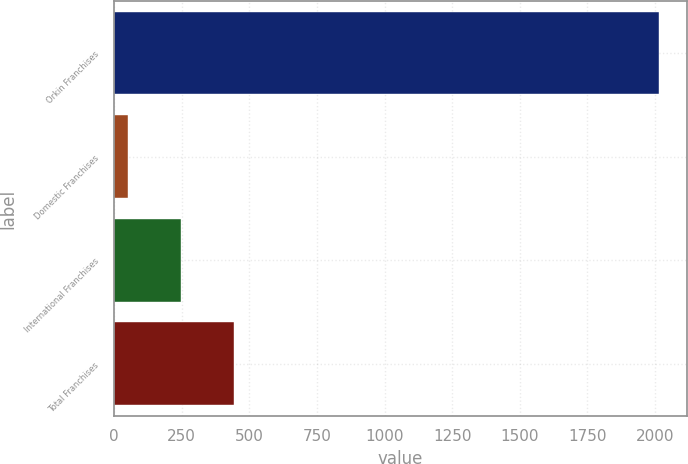Convert chart to OTSL. <chart><loc_0><loc_0><loc_500><loc_500><bar_chart><fcel>Orkin Franchises<fcel>Domestic Franchises<fcel>International Franchises<fcel>Total Franchises<nl><fcel>2016<fcel>50<fcel>246.6<fcel>443.2<nl></chart> 